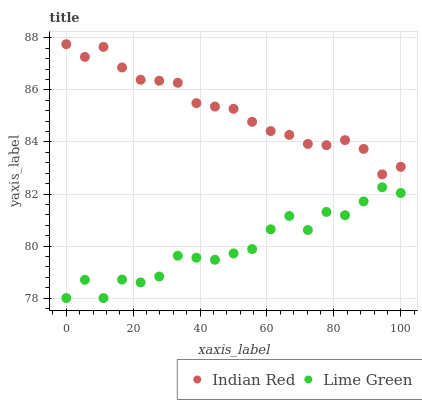Does Lime Green have the minimum area under the curve?
Answer yes or no. Yes. Does Indian Red have the maximum area under the curve?
Answer yes or no. Yes. Does Indian Red have the minimum area under the curve?
Answer yes or no. No. Is Indian Red the smoothest?
Answer yes or no. Yes. Is Lime Green the roughest?
Answer yes or no. Yes. Is Indian Red the roughest?
Answer yes or no. No. Does Lime Green have the lowest value?
Answer yes or no. Yes. Does Indian Red have the lowest value?
Answer yes or no. No. Does Indian Red have the highest value?
Answer yes or no. Yes. Is Lime Green less than Indian Red?
Answer yes or no. Yes. Is Indian Red greater than Lime Green?
Answer yes or no. Yes. Does Lime Green intersect Indian Red?
Answer yes or no. No. 